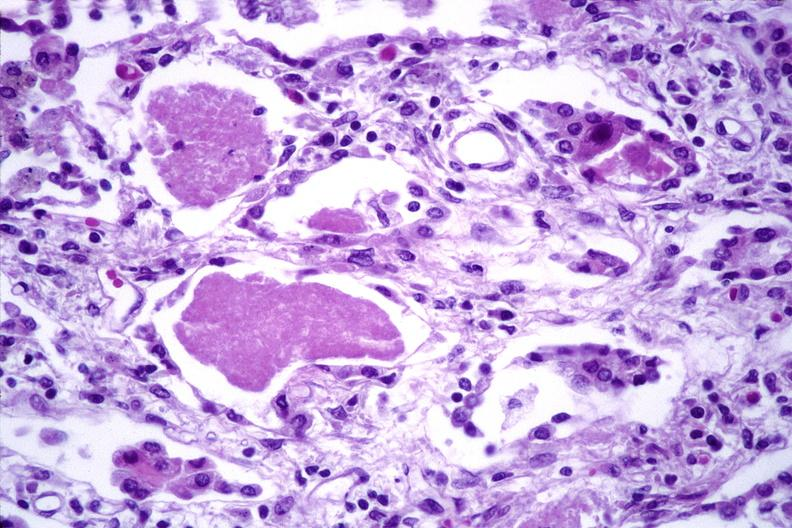s respiratory present?
Answer the question using a single word or phrase. Yes 